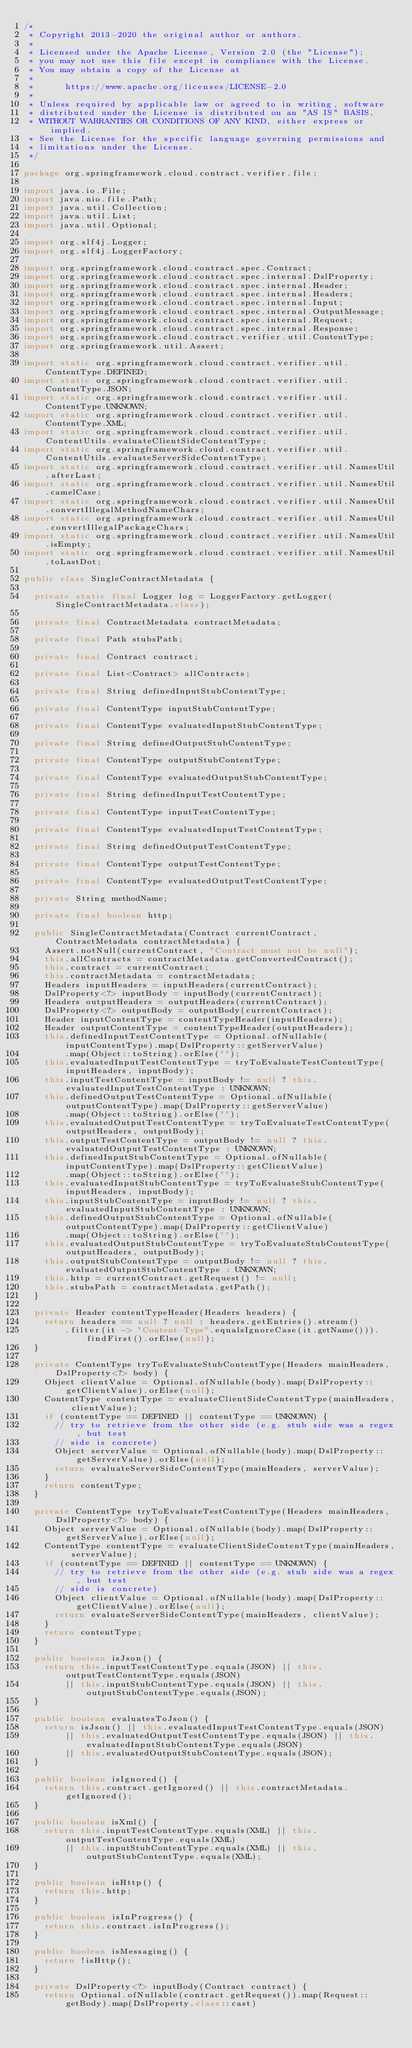<code> <loc_0><loc_0><loc_500><loc_500><_Java_>/*
 * Copyright 2013-2020 the original author or authors.
 *
 * Licensed under the Apache License, Version 2.0 (the "License");
 * you may not use this file except in compliance with the License.
 * You may obtain a copy of the License at
 *
 *      https://www.apache.org/licenses/LICENSE-2.0
 *
 * Unless required by applicable law or agreed to in writing, software
 * distributed under the License is distributed on an "AS IS" BASIS,
 * WITHOUT WARRANTIES OR CONDITIONS OF ANY KIND, either express or implied.
 * See the License for the specific language governing permissions and
 * limitations under the License.
 */

package org.springframework.cloud.contract.verifier.file;

import java.io.File;
import java.nio.file.Path;
import java.util.Collection;
import java.util.List;
import java.util.Optional;

import org.slf4j.Logger;
import org.slf4j.LoggerFactory;

import org.springframework.cloud.contract.spec.Contract;
import org.springframework.cloud.contract.spec.internal.DslProperty;
import org.springframework.cloud.contract.spec.internal.Header;
import org.springframework.cloud.contract.spec.internal.Headers;
import org.springframework.cloud.contract.spec.internal.Input;
import org.springframework.cloud.contract.spec.internal.OutputMessage;
import org.springframework.cloud.contract.spec.internal.Request;
import org.springframework.cloud.contract.spec.internal.Response;
import org.springframework.cloud.contract.verifier.util.ContentType;
import org.springframework.util.Assert;

import static org.springframework.cloud.contract.verifier.util.ContentType.DEFINED;
import static org.springframework.cloud.contract.verifier.util.ContentType.JSON;
import static org.springframework.cloud.contract.verifier.util.ContentType.UNKNOWN;
import static org.springframework.cloud.contract.verifier.util.ContentType.XML;
import static org.springframework.cloud.contract.verifier.util.ContentUtils.evaluateClientSideContentType;
import static org.springframework.cloud.contract.verifier.util.ContentUtils.evaluateServerSideContentType;
import static org.springframework.cloud.contract.verifier.util.NamesUtil.afterLast;
import static org.springframework.cloud.contract.verifier.util.NamesUtil.camelCase;
import static org.springframework.cloud.contract.verifier.util.NamesUtil.convertIllegalMethodNameChars;
import static org.springframework.cloud.contract.verifier.util.NamesUtil.convertIllegalPackageChars;
import static org.springframework.cloud.contract.verifier.util.NamesUtil.isEmpty;
import static org.springframework.cloud.contract.verifier.util.NamesUtil.toLastDot;

public class SingleContractMetadata {

	private static final Logger log = LoggerFactory.getLogger(SingleContractMetadata.class);

	private final ContractMetadata contractMetadata;

	private final Path stubsPath;

	private final Contract contract;

	private final List<Contract> allContracts;

	private final String definedInputStubContentType;

	private final ContentType inputStubContentType;

	private final ContentType evaluatedInputStubContentType;

	private final String definedOutputStubContentType;

	private final ContentType outputStubContentType;

	private final ContentType evaluatedOutputStubContentType;

	private final String definedInputTestContentType;

	private final ContentType inputTestContentType;

	private final ContentType evaluatedInputTestContentType;

	private final String definedOutputTestContentType;

	private final ContentType outputTestContentType;

	private final ContentType evaluatedOutputTestContentType;

	private String methodName;

	private final boolean http;

	public SingleContractMetadata(Contract currentContract, ContractMetadata contractMetadata) {
		Assert.notNull(currentContract, "Contract must not be null");
		this.allContracts = contractMetadata.getConvertedContract();
		this.contract = currentContract;
		this.contractMetadata = contractMetadata;
		Headers inputHeaders = inputHeaders(currentContract);
		DslProperty<?> inputBody = inputBody(currentContract);
		Headers outputHeaders = outputHeaders(currentContract);
		DslProperty<?> outputBody = outputBody(currentContract);
		Header inputContentType = contentTypeHeader(inputHeaders);
		Header outputContentType = contentTypeHeader(outputHeaders);
		this.definedInputTestContentType = Optional.ofNullable(inputContentType).map(DslProperty::getServerValue)
				.map(Object::toString).orElse("");
		this.evaluatedInputTestContentType = tryToEvaluateTestContentType(inputHeaders, inputBody);
		this.inputTestContentType = inputBody != null ? this.evaluatedInputTestContentType : UNKNOWN;
		this.definedOutputTestContentType = Optional.ofNullable(outputContentType).map(DslProperty::getServerValue)
				.map(Object::toString).orElse("");
		this.evaluatedOutputTestContentType = tryToEvaluateTestContentType(outputHeaders, outputBody);
		this.outputTestContentType = outputBody != null ? this.evaluatedOutputTestContentType : UNKNOWN;
		this.definedInputStubContentType = Optional.ofNullable(inputContentType).map(DslProperty::getClientValue)
				.map(Object::toString).orElse("");
		this.evaluatedInputStubContentType = tryToEvaluateStubContentType(inputHeaders, inputBody);
		this.inputStubContentType = inputBody != null ? this.evaluatedInputStubContentType : UNKNOWN;
		this.definedOutputStubContentType = Optional.ofNullable(outputContentType).map(DslProperty::getClientValue)
				.map(Object::toString).orElse("");
		this.evaluatedOutputStubContentType = tryToEvaluateStubContentType(outputHeaders, outputBody);
		this.outputStubContentType = outputBody != null ? this.evaluatedOutputStubContentType : UNKNOWN;
		this.http = currentContract.getRequest() != null;
		this.stubsPath = contractMetadata.getPath();
	}

	private Header contentTypeHeader(Headers headers) {
		return headers == null ? null : headers.getEntries().stream()
				.filter(it -> "Content-Type".equalsIgnoreCase(it.getName())).findFirst().orElse(null);
	}

	private ContentType tryToEvaluateStubContentType(Headers mainHeaders, DslProperty<?> body) {
		Object clientValue = Optional.ofNullable(body).map(DslProperty::getClientValue).orElse(null);
		ContentType contentType = evaluateClientSideContentType(mainHeaders, clientValue);
		if (contentType == DEFINED || contentType == UNKNOWN) {
			// try to retrieve from the other side (e.g. stub side was a regex, but test
			// side is concrete)
			Object serverValue = Optional.ofNullable(body).map(DslProperty::getServerValue).orElse(null);
			return evaluateServerSideContentType(mainHeaders, serverValue);
		}
		return contentType;
	}

	private ContentType tryToEvaluateTestContentType(Headers mainHeaders, DslProperty<?> body) {
		Object serverValue = Optional.ofNullable(body).map(DslProperty::getServerValue).orElse(null);
		ContentType contentType = evaluateClientSideContentType(mainHeaders, serverValue);
		if (contentType == DEFINED || contentType == UNKNOWN) {
			// try to retrieve from the other side (e.g. stub side was a regex, but test
			// side is concrete)
			Object clientValue = Optional.ofNullable(body).map(DslProperty::getClientValue).orElse(null);
			return evaluateServerSideContentType(mainHeaders, clientValue);
		}
		return contentType;
	}

	public boolean isJson() {
		return this.inputTestContentType.equals(JSON) || this.outputTestContentType.equals(JSON)
				|| this.inputStubContentType.equals(JSON) || this.outputStubContentType.equals(JSON);
	}

	public boolean evaluatesToJson() {
		return isJson() || this.evaluatedInputTestContentType.equals(JSON)
				|| this.evaluatedOutputTestContentType.equals(JSON) || this.evaluatedInputStubContentType.equals(JSON)
				|| this.evaluatedOutputStubContentType.equals(JSON);
	}

	public boolean isIgnored() {
		return this.contract.getIgnored() || this.contractMetadata.getIgnored();
	}

	public boolean isXml() {
		return this.inputTestContentType.equals(XML) || this.outputTestContentType.equals(XML)
				|| this.inputStubContentType.equals(XML) || this.outputStubContentType.equals(XML);
	}

	public boolean isHttp() {
		return this.http;
	}

	public boolean isInProgress() {
		return this.contract.isInProgress();
	}

	public boolean isMessaging() {
		return !isHttp();
	}

	private DslProperty<?> inputBody(Contract contract) {
		return Optional.ofNullable(contract.getRequest()).map(Request::getBody).map(DslProperty.class::cast)</code> 